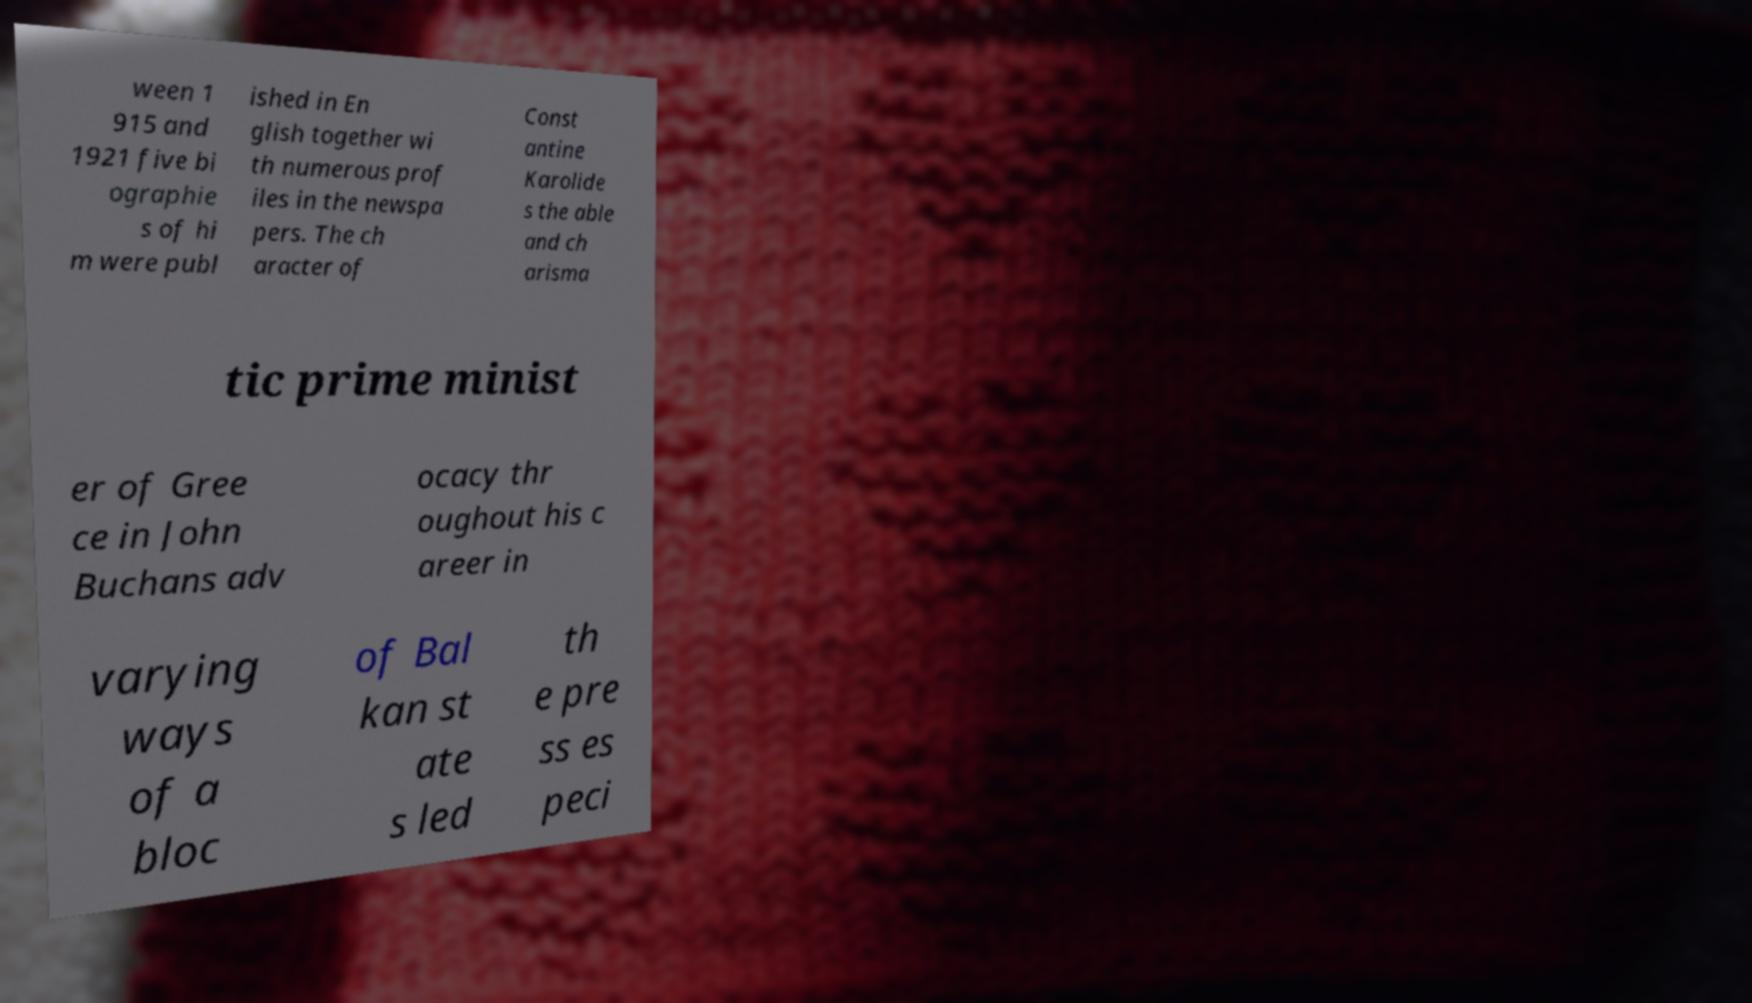What messages or text are displayed in this image? I need them in a readable, typed format. ween 1 915 and 1921 five bi ographie s of hi m were publ ished in En glish together wi th numerous prof iles in the newspa pers. The ch aracter of Const antine Karolide s the able and ch arisma tic prime minist er of Gree ce in John Buchans adv ocacy thr oughout his c areer in varying ways of a bloc of Bal kan st ate s led th e pre ss es peci 